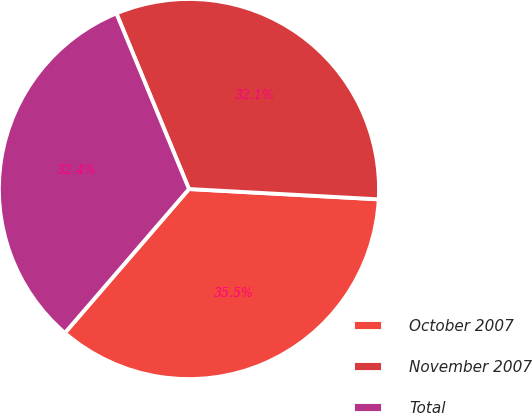Convert chart to OTSL. <chart><loc_0><loc_0><loc_500><loc_500><pie_chart><fcel>October 2007<fcel>November 2007<fcel>Total<nl><fcel>35.46%<fcel>32.1%<fcel>32.44%<nl></chart> 